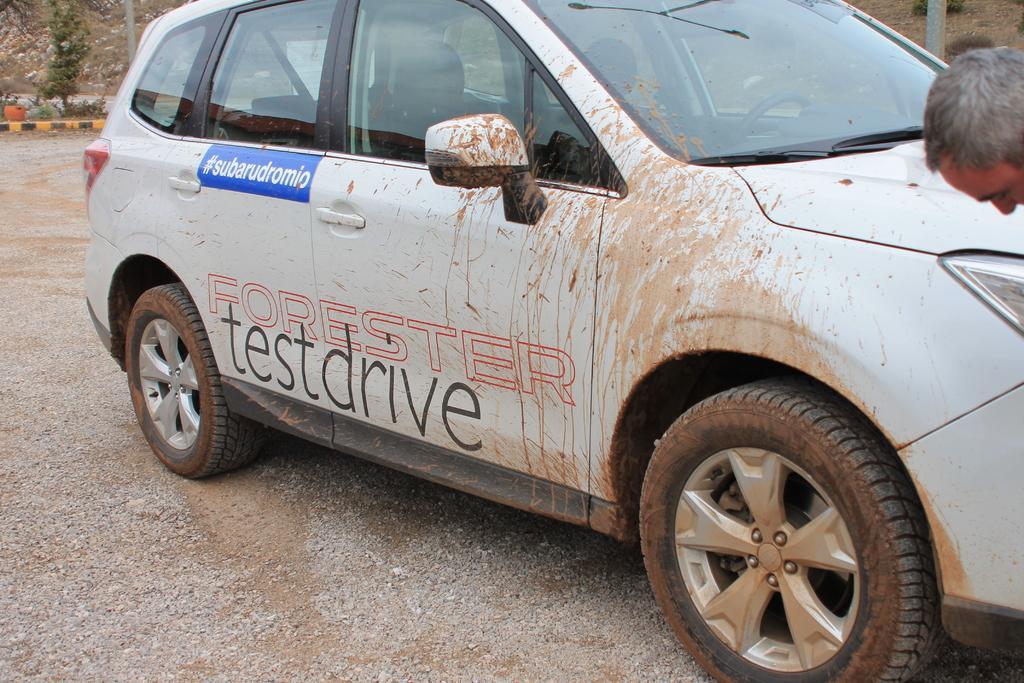In one or two sentences, can you explain what this image depicts? In this image there is road towards the bottom of the image, there is a car, there is text on the car, there is a man's face towards the right of the image, there are poles towards the top of the image, there are plants towards the left of the image, there are plants towards the top of the image, there is an object towards the left of the image. 